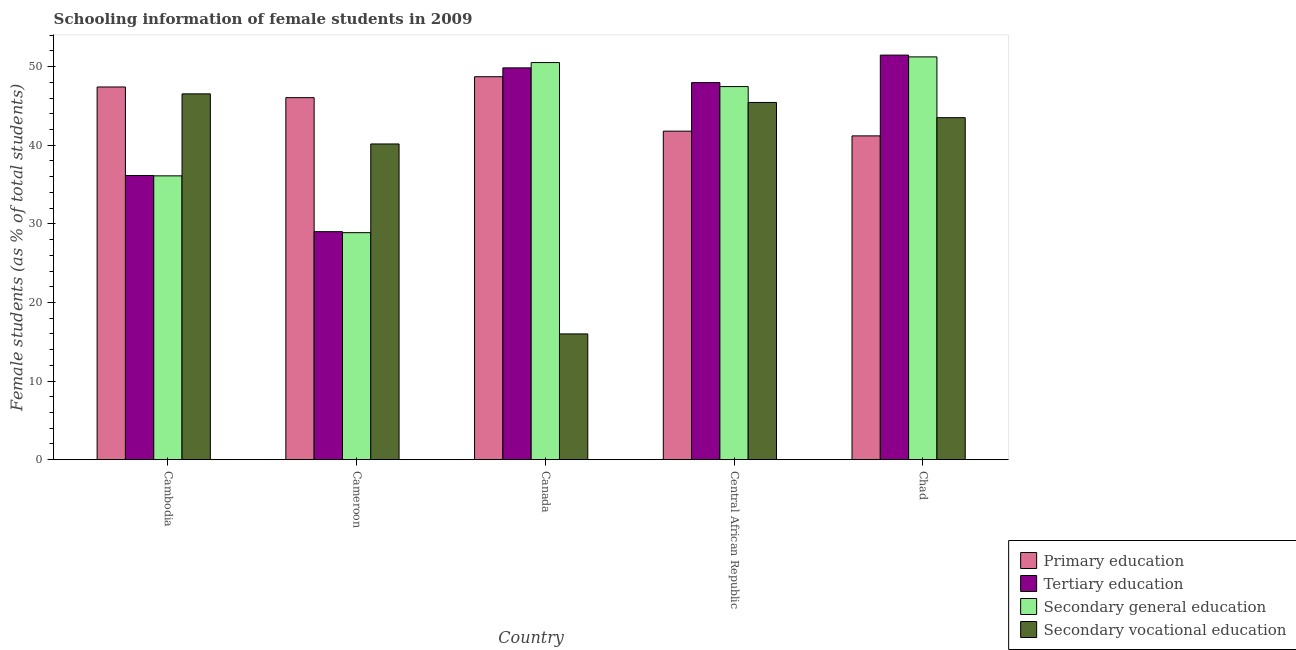How many bars are there on the 1st tick from the left?
Provide a succinct answer. 4. What is the label of the 2nd group of bars from the left?
Make the answer very short. Cameroon. In how many cases, is the number of bars for a given country not equal to the number of legend labels?
Make the answer very short. 0. What is the percentage of female students in secondary vocational education in Cameroon?
Your response must be concise. 40.16. Across all countries, what is the maximum percentage of female students in secondary education?
Ensure brevity in your answer.  51.24. Across all countries, what is the minimum percentage of female students in secondary vocational education?
Your response must be concise. 16. In which country was the percentage of female students in secondary education minimum?
Offer a terse response. Cameroon. What is the total percentage of female students in secondary education in the graph?
Ensure brevity in your answer.  214.22. What is the difference between the percentage of female students in secondary vocational education in Canada and that in Chad?
Provide a short and direct response. -27.51. What is the difference between the percentage of female students in secondary education in Central African Republic and the percentage of female students in primary education in Cameroon?
Offer a very short reply. 1.41. What is the average percentage of female students in primary education per country?
Offer a terse response. 45.03. What is the difference between the percentage of female students in primary education and percentage of female students in secondary education in Central African Republic?
Make the answer very short. -5.67. What is the ratio of the percentage of female students in secondary vocational education in Canada to that in Chad?
Offer a terse response. 0.37. What is the difference between the highest and the second highest percentage of female students in primary education?
Offer a very short reply. 1.31. What is the difference between the highest and the lowest percentage of female students in secondary vocational education?
Your answer should be compact. 30.54. Is the sum of the percentage of female students in secondary education in Cambodia and Canada greater than the maximum percentage of female students in primary education across all countries?
Offer a very short reply. Yes. What does the 1st bar from the left in Chad represents?
Give a very brief answer. Primary education. What does the 2nd bar from the right in Canada represents?
Your answer should be very brief. Secondary general education. How many countries are there in the graph?
Provide a short and direct response. 5. Does the graph contain any zero values?
Give a very brief answer. No. Does the graph contain grids?
Provide a succinct answer. No. Where does the legend appear in the graph?
Your response must be concise. Bottom right. How many legend labels are there?
Offer a terse response. 4. How are the legend labels stacked?
Your response must be concise. Vertical. What is the title of the graph?
Provide a succinct answer. Schooling information of female students in 2009. What is the label or title of the X-axis?
Provide a short and direct response. Country. What is the label or title of the Y-axis?
Your answer should be compact. Female students (as % of total students). What is the Female students (as % of total students) in Primary education in Cambodia?
Provide a succinct answer. 47.41. What is the Female students (as % of total students) in Tertiary education in Cambodia?
Your answer should be very brief. 36.15. What is the Female students (as % of total students) of Secondary general education in Cambodia?
Ensure brevity in your answer.  36.11. What is the Female students (as % of total students) of Secondary vocational education in Cambodia?
Make the answer very short. 46.54. What is the Female students (as % of total students) in Primary education in Cameroon?
Make the answer very short. 46.06. What is the Female students (as % of total students) in Tertiary education in Cameroon?
Your answer should be very brief. 29.01. What is the Female students (as % of total students) of Secondary general education in Cameroon?
Offer a very short reply. 28.88. What is the Female students (as % of total students) of Secondary vocational education in Cameroon?
Provide a succinct answer. 40.16. What is the Female students (as % of total students) in Primary education in Canada?
Ensure brevity in your answer.  48.72. What is the Female students (as % of total students) of Tertiary education in Canada?
Offer a very short reply. 49.84. What is the Female students (as % of total students) in Secondary general education in Canada?
Your answer should be compact. 50.52. What is the Female students (as % of total students) in Secondary vocational education in Canada?
Ensure brevity in your answer.  16. What is the Female students (as % of total students) in Primary education in Central African Republic?
Provide a succinct answer. 41.79. What is the Female students (as % of total students) of Tertiary education in Central African Republic?
Provide a succinct answer. 47.97. What is the Female students (as % of total students) of Secondary general education in Central African Republic?
Make the answer very short. 47.46. What is the Female students (as % of total students) in Secondary vocational education in Central African Republic?
Ensure brevity in your answer.  45.45. What is the Female students (as % of total students) in Primary education in Chad?
Your answer should be compact. 41.19. What is the Female students (as % of total students) of Tertiary education in Chad?
Provide a succinct answer. 51.47. What is the Female students (as % of total students) of Secondary general education in Chad?
Provide a succinct answer. 51.24. What is the Female students (as % of total students) of Secondary vocational education in Chad?
Your response must be concise. 43.51. Across all countries, what is the maximum Female students (as % of total students) of Primary education?
Offer a terse response. 48.72. Across all countries, what is the maximum Female students (as % of total students) in Tertiary education?
Your answer should be compact. 51.47. Across all countries, what is the maximum Female students (as % of total students) of Secondary general education?
Provide a short and direct response. 51.24. Across all countries, what is the maximum Female students (as % of total students) in Secondary vocational education?
Provide a short and direct response. 46.54. Across all countries, what is the minimum Female students (as % of total students) of Primary education?
Your answer should be compact. 41.19. Across all countries, what is the minimum Female students (as % of total students) of Tertiary education?
Provide a short and direct response. 29.01. Across all countries, what is the minimum Female students (as % of total students) in Secondary general education?
Give a very brief answer. 28.88. Across all countries, what is the minimum Female students (as % of total students) in Secondary vocational education?
Your answer should be very brief. 16. What is the total Female students (as % of total students) in Primary education in the graph?
Provide a succinct answer. 225.17. What is the total Female students (as % of total students) in Tertiary education in the graph?
Offer a very short reply. 214.44. What is the total Female students (as % of total students) of Secondary general education in the graph?
Ensure brevity in your answer.  214.22. What is the total Female students (as % of total students) of Secondary vocational education in the graph?
Your response must be concise. 191.65. What is the difference between the Female students (as % of total students) of Primary education in Cambodia and that in Cameroon?
Offer a very short reply. 1.36. What is the difference between the Female students (as % of total students) of Tertiary education in Cambodia and that in Cameroon?
Your answer should be very brief. 7.14. What is the difference between the Female students (as % of total students) in Secondary general education in Cambodia and that in Cameroon?
Offer a terse response. 7.23. What is the difference between the Female students (as % of total students) in Secondary vocational education in Cambodia and that in Cameroon?
Make the answer very short. 6.37. What is the difference between the Female students (as % of total students) of Primary education in Cambodia and that in Canada?
Give a very brief answer. -1.31. What is the difference between the Female students (as % of total students) in Tertiary education in Cambodia and that in Canada?
Give a very brief answer. -13.69. What is the difference between the Female students (as % of total students) in Secondary general education in Cambodia and that in Canada?
Provide a short and direct response. -14.41. What is the difference between the Female students (as % of total students) in Secondary vocational education in Cambodia and that in Canada?
Give a very brief answer. 30.54. What is the difference between the Female students (as % of total students) of Primary education in Cambodia and that in Central African Republic?
Offer a terse response. 5.62. What is the difference between the Female students (as % of total students) in Tertiary education in Cambodia and that in Central African Republic?
Your answer should be compact. -11.82. What is the difference between the Female students (as % of total students) in Secondary general education in Cambodia and that in Central African Republic?
Your answer should be compact. -11.36. What is the difference between the Female students (as % of total students) in Secondary vocational education in Cambodia and that in Central African Republic?
Give a very brief answer. 1.09. What is the difference between the Female students (as % of total students) in Primary education in Cambodia and that in Chad?
Your answer should be very brief. 6.22. What is the difference between the Female students (as % of total students) in Tertiary education in Cambodia and that in Chad?
Give a very brief answer. -15.32. What is the difference between the Female students (as % of total students) in Secondary general education in Cambodia and that in Chad?
Make the answer very short. -15.14. What is the difference between the Female students (as % of total students) in Secondary vocational education in Cambodia and that in Chad?
Provide a short and direct response. 3.03. What is the difference between the Female students (as % of total students) of Primary education in Cameroon and that in Canada?
Make the answer very short. -2.66. What is the difference between the Female students (as % of total students) of Tertiary education in Cameroon and that in Canada?
Your answer should be very brief. -20.84. What is the difference between the Female students (as % of total students) of Secondary general education in Cameroon and that in Canada?
Offer a very short reply. -21.64. What is the difference between the Female students (as % of total students) of Secondary vocational education in Cameroon and that in Canada?
Keep it short and to the point. 24.16. What is the difference between the Female students (as % of total students) of Primary education in Cameroon and that in Central African Republic?
Offer a very short reply. 4.26. What is the difference between the Female students (as % of total students) of Tertiary education in Cameroon and that in Central African Republic?
Provide a succinct answer. -18.96. What is the difference between the Female students (as % of total students) of Secondary general education in Cameroon and that in Central African Republic?
Ensure brevity in your answer.  -18.58. What is the difference between the Female students (as % of total students) of Secondary vocational education in Cameroon and that in Central African Republic?
Your response must be concise. -5.28. What is the difference between the Female students (as % of total students) of Primary education in Cameroon and that in Chad?
Offer a terse response. 4.86. What is the difference between the Female students (as % of total students) in Tertiary education in Cameroon and that in Chad?
Your response must be concise. -22.46. What is the difference between the Female students (as % of total students) of Secondary general education in Cameroon and that in Chad?
Give a very brief answer. -22.36. What is the difference between the Female students (as % of total students) of Secondary vocational education in Cameroon and that in Chad?
Your answer should be compact. -3.34. What is the difference between the Female students (as % of total students) of Primary education in Canada and that in Central African Republic?
Your response must be concise. 6.93. What is the difference between the Female students (as % of total students) of Tertiary education in Canada and that in Central African Republic?
Keep it short and to the point. 1.87. What is the difference between the Female students (as % of total students) of Secondary general education in Canada and that in Central African Republic?
Provide a short and direct response. 3.06. What is the difference between the Female students (as % of total students) in Secondary vocational education in Canada and that in Central African Republic?
Ensure brevity in your answer.  -29.44. What is the difference between the Female students (as % of total students) of Primary education in Canada and that in Chad?
Your answer should be very brief. 7.53. What is the difference between the Female students (as % of total students) of Tertiary education in Canada and that in Chad?
Make the answer very short. -1.62. What is the difference between the Female students (as % of total students) in Secondary general education in Canada and that in Chad?
Keep it short and to the point. -0.72. What is the difference between the Female students (as % of total students) of Secondary vocational education in Canada and that in Chad?
Ensure brevity in your answer.  -27.51. What is the difference between the Female students (as % of total students) in Primary education in Central African Republic and that in Chad?
Make the answer very short. 0.6. What is the difference between the Female students (as % of total students) in Tertiary education in Central African Republic and that in Chad?
Ensure brevity in your answer.  -3.5. What is the difference between the Female students (as % of total students) of Secondary general education in Central African Republic and that in Chad?
Your answer should be very brief. -3.78. What is the difference between the Female students (as % of total students) of Secondary vocational education in Central African Republic and that in Chad?
Provide a succinct answer. 1.94. What is the difference between the Female students (as % of total students) of Primary education in Cambodia and the Female students (as % of total students) of Tertiary education in Cameroon?
Provide a succinct answer. 18.41. What is the difference between the Female students (as % of total students) of Primary education in Cambodia and the Female students (as % of total students) of Secondary general education in Cameroon?
Offer a terse response. 18.53. What is the difference between the Female students (as % of total students) of Primary education in Cambodia and the Female students (as % of total students) of Secondary vocational education in Cameroon?
Provide a succinct answer. 7.25. What is the difference between the Female students (as % of total students) of Tertiary education in Cambodia and the Female students (as % of total students) of Secondary general education in Cameroon?
Give a very brief answer. 7.27. What is the difference between the Female students (as % of total students) in Tertiary education in Cambodia and the Female students (as % of total students) in Secondary vocational education in Cameroon?
Make the answer very short. -4.01. What is the difference between the Female students (as % of total students) of Secondary general education in Cambodia and the Female students (as % of total students) of Secondary vocational education in Cameroon?
Your answer should be very brief. -4.06. What is the difference between the Female students (as % of total students) in Primary education in Cambodia and the Female students (as % of total students) in Tertiary education in Canada?
Offer a very short reply. -2.43. What is the difference between the Female students (as % of total students) of Primary education in Cambodia and the Female students (as % of total students) of Secondary general education in Canada?
Your response must be concise. -3.11. What is the difference between the Female students (as % of total students) in Primary education in Cambodia and the Female students (as % of total students) in Secondary vocational education in Canada?
Your answer should be compact. 31.41. What is the difference between the Female students (as % of total students) in Tertiary education in Cambodia and the Female students (as % of total students) in Secondary general education in Canada?
Keep it short and to the point. -14.37. What is the difference between the Female students (as % of total students) of Tertiary education in Cambodia and the Female students (as % of total students) of Secondary vocational education in Canada?
Provide a succinct answer. 20.15. What is the difference between the Female students (as % of total students) in Secondary general education in Cambodia and the Female students (as % of total students) in Secondary vocational education in Canada?
Ensure brevity in your answer.  20.11. What is the difference between the Female students (as % of total students) of Primary education in Cambodia and the Female students (as % of total students) of Tertiary education in Central African Republic?
Your answer should be compact. -0.56. What is the difference between the Female students (as % of total students) of Primary education in Cambodia and the Female students (as % of total students) of Secondary general education in Central African Republic?
Keep it short and to the point. -0.05. What is the difference between the Female students (as % of total students) in Primary education in Cambodia and the Female students (as % of total students) in Secondary vocational education in Central African Republic?
Make the answer very short. 1.97. What is the difference between the Female students (as % of total students) of Tertiary education in Cambodia and the Female students (as % of total students) of Secondary general education in Central African Republic?
Provide a short and direct response. -11.31. What is the difference between the Female students (as % of total students) in Tertiary education in Cambodia and the Female students (as % of total students) in Secondary vocational education in Central African Republic?
Ensure brevity in your answer.  -9.29. What is the difference between the Female students (as % of total students) in Secondary general education in Cambodia and the Female students (as % of total students) in Secondary vocational education in Central African Republic?
Your response must be concise. -9.34. What is the difference between the Female students (as % of total students) of Primary education in Cambodia and the Female students (as % of total students) of Tertiary education in Chad?
Your response must be concise. -4.05. What is the difference between the Female students (as % of total students) in Primary education in Cambodia and the Female students (as % of total students) in Secondary general education in Chad?
Ensure brevity in your answer.  -3.83. What is the difference between the Female students (as % of total students) of Primary education in Cambodia and the Female students (as % of total students) of Secondary vocational education in Chad?
Your answer should be compact. 3.91. What is the difference between the Female students (as % of total students) of Tertiary education in Cambodia and the Female students (as % of total students) of Secondary general education in Chad?
Your answer should be compact. -15.09. What is the difference between the Female students (as % of total students) of Tertiary education in Cambodia and the Female students (as % of total students) of Secondary vocational education in Chad?
Make the answer very short. -7.36. What is the difference between the Female students (as % of total students) in Secondary general education in Cambodia and the Female students (as % of total students) in Secondary vocational education in Chad?
Offer a very short reply. -7.4. What is the difference between the Female students (as % of total students) of Primary education in Cameroon and the Female students (as % of total students) of Tertiary education in Canada?
Your response must be concise. -3.79. What is the difference between the Female students (as % of total students) in Primary education in Cameroon and the Female students (as % of total students) in Secondary general education in Canada?
Provide a succinct answer. -4.47. What is the difference between the Female students (as % of total students) in Primary education in Cameroon and the Female students (as % of total students) in Secondary vocational education in Canada?
Ensure brevity in your answer.  30.05. What is the difference between the Female students (as % of total students) in Tertiary education in Cameroon and the Female students (as % of total students) in Secondary general education in Canada?
Offer a very short reply. -21.51. What is the difference between the Female students (as % of total students) of Tertiary education in Cameroon and the Female students (as % of total students) of Secondary vocational education in Canada?
Your answer should be compact. 13.01. What is the difference between the Female students (as % of total students) of Secondary general education in Cameroon and the Female students (as % of total students) of Secondary vocational education in Canada?
Your response must be concise. 12.88. What is the difference between the Female students (as % of total students) of Primary education in Cameroon and the Female students (as % of total students) of Tertiary education in Central African Republic?
Offer a very short reply. -1.92. What is the difference between the Female students (as % of total students) of Primary education in Cameroon and the Female students (as % of total students) of Secondary general education in Central African Republic?
Ensure brevity in your answer.  -1.41. What is the difference between the Female students (as % of total students) in Primary education in Cameroon and the Female students (as % of total students) in Secondary vocational education in Central African Republic?
Provide a short and direct response. 0.61. What is the difference between the Female students (as % of total students) in Tertiary education in Cameroon and the Female students (as % of total students) in Secondary general education in Central African Republic?
Your answer should be compact. -18.46. What is the difference between the Female students (as % of total students) in Tertiary education in Cameroon and the Female students (as % of total students) in Secondary vocational education in Central African Republic?
Offer a very short reply. -16.44. What is the difference between the Female students (as % of total students) in Secondary general education in Cameroon and the Female students (as % of total students) in Secondary vocational education in Central African Republic?
Provide a succinct answer. -16.56. What is the difference between the Female students (as % of total students) in Primary education in Cameroon and the Female students (as % of total students) in Tertiary education in Chad?
Provide a succinct answer. -5.41. What is the difference between the Female students (as % of total students) of Primary education in Cameroon and the Female students (as % of total students) of Secondary general education in Chad?
Keep it short and to the point. -5.19. What is the difference between the Female students (as % of total students) in Primary education in Cameroon and the Female students (as % of total students) in Secondary vocational education in Chad?
Keep it short and to the point. 2.55. What is the difference between the Female students (as % of total students) of Tertiary education in Cameroon and the Female students (as % of total students) of Secondary general education in Chad?
Offer a very short reply. -22.24. What is the difference between the Female students (as % of total students) of Tertiary education in Cameroon and the Female students (as % of total students) of Secondary vocational education in Chad?
Give a very brief answer. -14.5. What is the difference between the Female students (as % of total students) in Secondary general education in Cameroon and the Female students (as % of total students) in Secondary vocational education in Chad?
Make the answer very short. -14.63. What is the difference between the Female students (as % of total students) in Primary education in Canada and the Female students (as % of total students) in Tertiary education in Central African Republic?
Give a very brief answer. 0.75. What is the difference between the Female students (as % of total students) in Primary education in Canada and the Female students (as % of total students) in Secondary general education in Central African Republic?
Make the answer very short. 1.25. What is the difference between the Female students (as % of total students) of Primary education in Canada and the Female students (as % of total students) of Secondary vocational education in Central African Republic?
Provide a short and direct response. 3.27. What is the difference between the Female students (as % of total students) in Tertiary education in Canada and the Female students (as % of total students) in Secondary general education in Central African Republic?
Your response must be concise. 2.38. What is the difference between the Female students (as % of total students) in Tertiary education in Canada and the Female students (as % of total students) in Secondary vocational education in Central African Republic?
Your response must be concise. 4.4. What is the difference between the Female students (as % of total students) in Secondary general education in Canada and the Female students (as % of total students) in Secondary vocational education in Central African Republic?
Give a very brief answer. 5.08. What is the difference between the Female students (as % of total students) of Primary education in Canada and the Female students (as % of total students) of Tertiary education in Chad?
Your answer should be very brief. -2.75. What is the difference between the Female students (as % of total students) of Primary education in Canada and the Female students (as % of total students) of Secondary general education in Chad?
Your response must be concise. -2.52. What is the difference between the Female students (as % of total students) in Primary education in Canada and the Female students (as % of total students) in Secondary vocational education in Chad?
Keep it short and to the point. 5.21. What is the difference between the Female students (as % of total students) of Tertiary education in Canada and the Female students (as % of total students) of Secondary general education in Chad?
Make the answer very short. -1.4. What is the difference between the Female students (as % of total students) in Tertiary education in Canada and the Female students (as % of total students) in Secondary vocational education in Chad?
Your answer should be very brief. 6.34. What is the difference between the Female students (as % of total students) in Secondary general education in Canada and the Female students (as % of total students) in Secondary vocational education in Chad?
Give a very brief answer. 7.01. What is the difference between the Female students (as % of total students) in Primary education in Central African Republic and the Female students (as % of total students) in Tertiary education in Chad?
Offer a very short reply. -9.67. What is the difference between the Female students (as % of total students) in Primary education in Central African Republic and the Female students (as % of total students) in Secondary general education in Chad?
Keep it short and to the point. -9.45. What is the difference between the Female students (as % of total students) of Primary education in Central African Republic and the Female students (as % of total students) of Secondary vocational education in Chad?
Offer a very short reply. -1.71. What is the difference between the Female students (as % of total students) of Tertiary education in Central African Republic and the Female students (as % of total students) of Secondary general education in Chad?
Make the answer very short. -3.27. What is the difference between the Female students (as % of total students) in Tertiary education in Central African Republic and the Female students (as % of total students) in Secondary vocational education in Chad?
Provide a succinct answer. 4.46. What is the difference between the Female students (as % of total students) of Secondary general education in Central African Republic and the Female students (as % of total students) of Secondary vocational education in Chad?
Ensure brevity in your answer.  3.96. What is the average Female students (as % of total students) of Primary education per country?
Your response must be concise. 45.03. What is the average Female students (as % of total students) of Tertiary education per country?
Make the answer very short. 42.89. What is the average Female students (as % of total students) in Secondary general education per country?
Offer a very short reply. 42.84. What is the average Female students (as % of total students) in Secondary vocational education per country?
Your response must be concise. 38.33. What is the difference between the Female students (as % of total students) in Primary education and Female students (as % of total students) in Tertiary education in Cambodia?
Offer a terse response. 11.26. What is the difference between the Female students (as % of total students) of Primary education and Female students (as % of total students) of Secondary general education in Cambodia?
Keep it short and to the point. 11.31. What is the difference between the Female students (as % of total students) of Primary education and Female students (as % of total students) of Secondary vocational education in Cambodia?
Your answer should be compact. 0.88. What is the difference between the Female students (as % of total students) of Tertiary education and Female students (as % of total students) of Secondary general education in Cambodia?
Ensure brevity in your answer.  0.04. What is the difference between the Female students (as % of total students) in Tertiary education and Female students (as % of total students) in Secondary vocational education in Cambodia?
Your response must be concise. -10.38. What is the difference between the Female students (as % of total students) of Secondary general education and Female students (as % of total students) of Secondary vocational education in Cambodia?
Offer a very short reply. -10.43. What is the difference between the Female students (as % of total students) in Primary education and Female students (as % of total students) in Tertiary education in Cameroon?
Ensure brevity in your answer.  17.05. What is the difference between the Female students (as % of total students) in Primary education and Female students (as % of total students) in Secondary general education in Cameroon?
Keep it short and to the point. 17.17. What is the difference between the Female students (as % of total students) of Primary education and Female students (as % of total students) of Secondary vocational education in Cameroon?
Provide a short and direct response. 5.89. What is the difference between the Female students (as % of total students) in Tertiary education and Female students (as % of total students) in Secondary general education in Cameroon?
Provide a succinct answer. 0.13. What is the difference between the Female students (as % of total students) in Tertiary education and Female students (as % of total students) in Secondary vocational education in Cameroon?
Keep it short and to the point. -11.16. What is the difference between the Female students (as % of total students) in Secondary general education and Female students (as % of total students) in Secondary vocational education in Cameroon?
Make the answer very short. -11.28. What is the difference between the Female students (as % of total students) of Primary education and Female students (as % of total students) of Tertiary education in Canada?
Give a very brief answer. -1.12. What is the difference between the Female students (as % of total students) in Primary education and Female students (as % of total students) in Secondary general education in Canada?
Your answer should be very brief. -1.8. What is the difference between the Female students (as % of total students) in Primary education and Female students (as % of total students) in Secondary vocational education in Canada?
Give a very brief answer. 32.72. What is the difference between the Female students (as % of total students) in Tertiary education and Female students (as % of total students) in Secondary general education in Canada?
Your response must be concise. -0.68. What is the difference between the Female students (as % of total students) in Tertiary education and Female students (as % of total students) in Secondary vocational education in Canada?
Ensure brevity in your answer.  33.84. What is the difference between the Female students (as % of total students) in Secondary general education and Female students (as % of total students) in Secondary vocational education in Canada?
Ensure brevity in your answer.  34.52. What is the difference between the Female students (as % of total students) of Primary education and Female students (as % of total students) of Tertiary education in Central African Republic?
Make the answer very short. -6.18. What is the difference between the Female students (as % of total students) in Primary education and Female students (as % of total students) in Secondary general education in Central African Republic?
Provide a short and direct response. -5.67. What is the difference between the Female students (as % of total students) of Primary education and Female students (as % of total students) of Secondary vocational education in Central African Republic?
Make the answer very short. -3.65. What is the difference between the Female students (as % of total students) in Tertiary education and Female students (as % of total students) in Secondary general education in Central African Republic?
Offer a terse response. 0.51. What is the difference between the Female students (as % of total students) of Tertiary education and Female students (as % of total students) of Secondary vocational education in Central African Republic?
Provide a short and direct response. 2.53. What is the difference between the Female students (as % of total students) in Secondary general education and Female students (as % of total students) in Secondary vocational education in Central African Republic?
Ensure brevity in your answer.  2.02. What is the difference between the Female students (as % of total students) in Primary education and Female students (as % of total students) in Tertiary education in Chad?
Your answer should be very brief. -10.28. What is the difference between the Female students (as % of total students) in Primary education and Female students (as % of total students) in Secondary general education in Chad?
Ensure brevity in your answer.  -10.05. What is the difference between the Female students (as % of total students) of Primary education and Female students (as % of total students) of Secondary vocational education in Chad?
Your answer should be very brief. -2.32. What is the difference between the Female students (as % of total students) of Tertiary education and Female students (as % of total students) of Secondary general education in Chad?
Give a very brief answer. 0.23. What is the difference between the Female students (as % of total students) in Tertiary education and Female students (as % of total students) in Secondary vocational education in Chad?
Give a very brief answer. 7.96. What is the difference between the Female students (as % of total students) in Secondary general education and Female students (as % of total students) in Secondary vocational education in Chad?
Provide a succinct answer. 7.74. What is the ratio of the Female students (as % of total students) in Primary education in Cambodia to that in Cameroon?
Provide a succinct answer. 1.03. What is the ratio of the Female students (as % of total students) in Tertiary education in Cambodia to that in Cameroon?
Give a very brief answer. 1.25. What is the ratio of the Female students (as % of total students) of Secondary general education in Cambodia to that in Cameroon?
Your response must be concise. 1.25. What is the ratio of the Female students (as % of total students) in Secondary vocational education in Cambodia to that in Cameroon?
Make the answer very short. 1.16. What is the ratio of the Female students (as % of total students) of Primary education in Cambodia to that in Canada?
Provide a short and direct response. 0.97. What is the ratio of the Female students (as % of total students) in Tertiary education in Cambodia to that in Canada?
Offer a terse response. 0.73. What is the ratio of the Female students (as % of total students) of Secondary general education in Cambodia to that in Canada?
Keep it short and to the point. 0.71. What is the ratio of the Female students (as % of total students) of Secondary vocational education in Cambodia to that in Canada?
Offer a very short reply. 2.91. What is the ratio of the Female students (as % of total students) in Primary education in Cambodia to that in Central African Republic?
Provide a succinct answer. 1.13. What is the ratio of the Female students (as % of total students) of Tertiary education in Cambodia to that in Central African Republic?
Keep it short and to the point. 0.75. What is the ratio of the Female students (as % of total students) of Secondary general education in Cambodia to that in Central African Republic?
Keep it short and to the point. 0.76. What is the ratio of the Female students (as % of total students) of Secondary vocational education in Cambodia to that in Central African Republic?
Offer a very short reply. 1.02. What is the ratio of the Female students (as % of total students) of Primary education in Cambodia to that in Chad?
Provide a short and direct response. 1.15. What is the ratio of the Female students (as % of total students) in Tertiary education in Cambodia to that in Chad?
Provide a short and direct response. 0.7. What is the ratio of the Female students (as % of total students) of Secondary general education in Cambodia to that in Chad?
Your answer should be compact. 0.7. What is the ratio of the Female students (as % of total students) of Secondary vocational education in Cambodia to that in Chad?
Your answer should be compact. 1.07. What is the ratio of the Female students (as % of total students) of Primary education in Cameroon to that in Canada?
Your response must be concise. 0.95. What is the ratio of the Female students (as % of total students) in Tertiary education in Cameroon to that in Canada?
Ensure brevity in your answer.  0.58. What is the ratio of the Female students (as % of total students) in Secondary general education in Cameroon to that in Canada?
Ensure brevity in your answer.  0.57. What is the ratio of the Female students (as % of total students) of Secondary vocational education in Cameroon to that in Canada?
Keep it short and to the point. 2.51. What is the ratio of the Female students (as % of total students) in Primary education in Cameroon to that in Central African Republic?
Offer a terse response. 1.1. What is the ratio of the Female students (as % of total students) in Tertiary education in Cameroon to that in Central African Republic?
Give a very brief answer. 0.6. What is the ratio of the Female students (as % of total students) of Secondary general education in Cameroon to that in Central African Republic?
Keep it short and to the point. 0.61. What is the ratio of the Female students (as % of total students) in Secondary vocational education in Cameroon to that in Central African Republic?
Provide a succinct answer. 0.88. What is the ratio of the Female students (as % of total students) of Primary education in Cameroon to that in Chad?
Provide a short and direct response. 1.12. What is the ratio of the Female students (as % of total students) in Tertiary education in Cameroon to that in Chad?
Provide a succinct answer. 0.56. What is the ratio of the Female students (as % of total students) of Secondary general education in Cameroon to that in Chad?
Offer a very short reply. 0.56. What is the ratio of the Female students (as % of total students) in Secondary vocational education in Cameroon to that in Chad?
Give a very brief answer. 0.92. What is the ratio of the Female students (as % of total students) in Primary education in Canada to that in Central African Republic?
Offer a very short reply. 1.17. What is the ratio of the Female students (as % of total students) of Tertiary education in Canada to that in Central African Republic?
Your answer should be very brief. 1.04. What is the ratio of the Female students (as % of total students) in Secondary general education in Canada to that in Central African Republic?
Your answer should be very brief. 1.06. What is the ratio of the Female students (as % of total students) of Secondary vocational education in Canada to that in Central African Republic?
Provide a succinct answer. 0.35. What is the ratio of the Female students (as % of total students) of Primary education in Canada to that in Chad?
Offer a terse response. 1.18. What is the ratio of the Female students (as % of total students) of Tertiary education in Canada to that in Chad?
Your answer should be very brief. 0.97. What is the ratio of the Female students (as % of total students) of Secondary general education in Canada to that in Chad?
Make the answer very short. 0.99. What is the ratio of the Female students (as % of total students) of Secondary vocational education in Canada to that in Chad?
Offer a very short reply. 0.37. What is the ratio of the Female students (as % of total students) of Primary education in Central African Republic to that in Chad?
Offer a very short reply. 1.01. What is the ratio of the Female students (as % of total students) of Tertiary education in Central African Republic to that in Chad?
Your answer should be very brief. 0.93. What is the ratio of the Female students (as % of total students) of Secondary general education in Central African Republic to that in Chad?
Provide a succinct answer. 0.93. What is the ratio of the Female students (as % of total students) of Secondary vocational education in Central African Republic to that in Chad?
Ensure brevity in your answer.  1.04. What is the difference between the highest and the second highest Female students (as % of total students) of Primary education?
Your answer should be compact. 1.31. What is the difference between the highest and the second highest Female students (as % of total students) in Tertiary education?
Offer a very short reply. 1.62. What is the difference between the highest and the second highest Female students (as % of total students) of Secondary general education?
Offer a very short reply. 0.72. What is the difference between the highest and the second highest Female students (as % of total students) in Secondary vocational education?
Offer a terse response. 1.09. What is the difference between the highest and the lowest Female students (as % of total students) of Primary education?
Your response must be concise. 7.53. What is the difference between the highest and the lowest Female students (as % of total students) in Tertiary education?
Keep it short and to the point. 22.46. What is the difference between the highest and the lowest Female students (as % of total students) in Secondary general education?
Your response must be concise. 22.36. What is the difference between the highest and the lowest Female students (as % of total students) in Secondary vocational education?
Offer a very short reply. 30.54. 